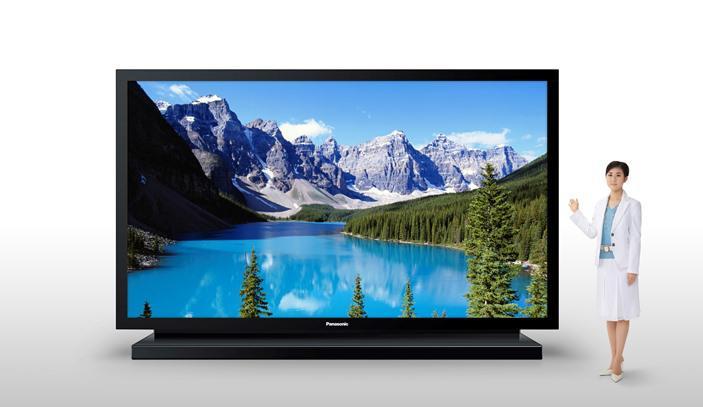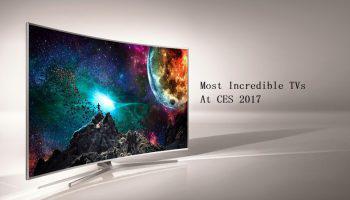The first image is the image on the left, the second image is the image on the right. For the images shown, is this caption "One screen is flat and viewed head-on, and the other screen is curved and displayed at an angle." true? Answer yes or no. Yes. The first image is the image on the left, the second image is the image on the right. Evaluate the accuracy of this statement regarding the images: "The left and right image contains the same number television with at least one curved television.". Is it true? Answer yes or no. Yes. 